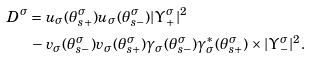Convert formula to latex. <formula><loc_0><loc_0><loc_500><loc_500>D ^ { \sigma } & = u _ { \sigma } ( \theta _ { s + } ^ { \sigma } ) u _ { \sigma } ( \theta _ { s - } ^ { \sigma } ) | \Upsilon _ { + } ^ { \sigma } | ^ { 2 } \\ & \, - v _ { \sigma } ( \theta _ { s - } ^ { \sigma } ) v _ { \sigma } ( \theta _ { s + } ^ { \sigma } ) \gamma _ { \sigma } ( \theta _ { s - } ^ { \sigma } ) \gamma _ { \sigma } ^ { * } ( \theta _ { s + } ^ { \sigma } ) \times | \Upsilon _ { - } ^ { \sigma } | ^ { 2 } .</formula> 